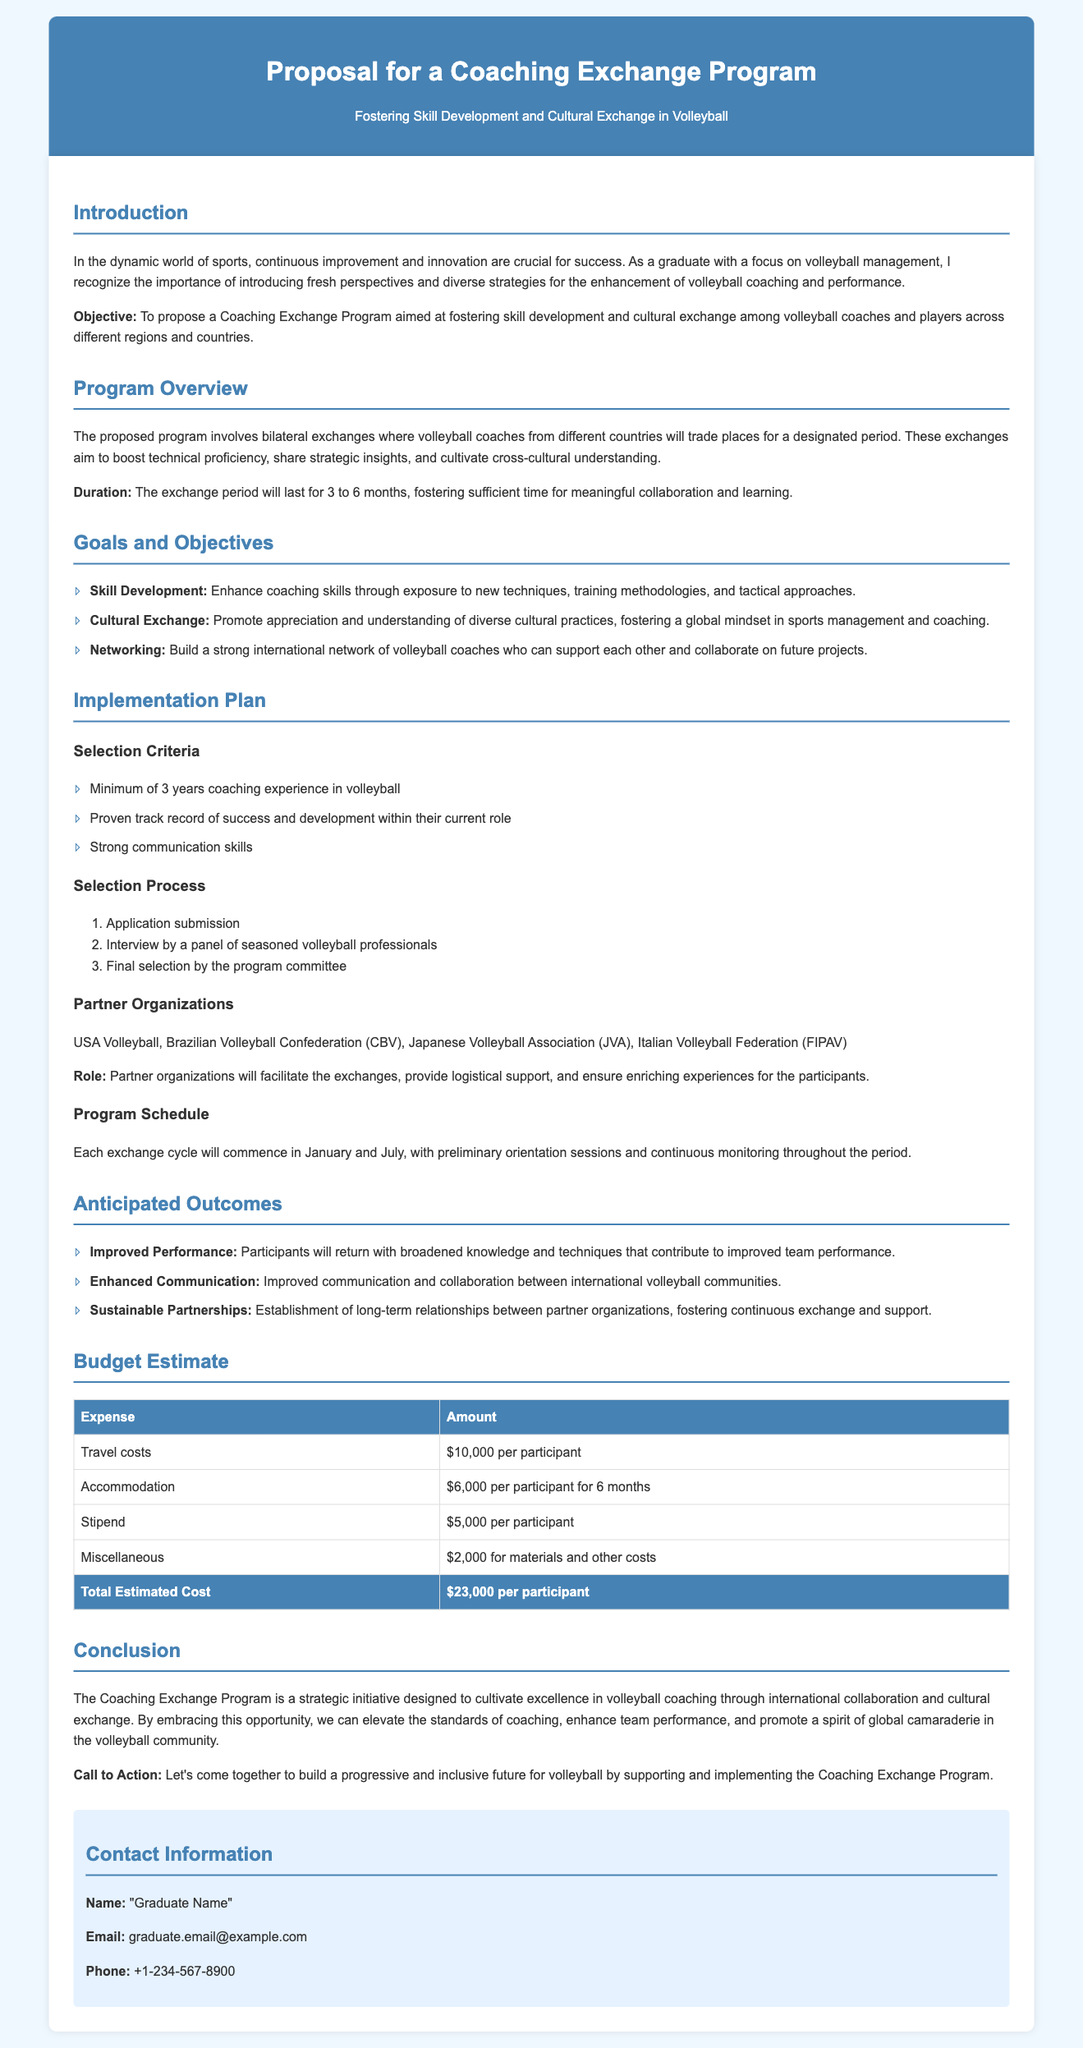what is the duration of the exchange period? The exchange period will last for 3 to 6 months, fostering sufficient time for meaningful collaboration and learning.
Answer: 3 to 6 months who are the partner organizations mentioned? Partner organizations include USA Volleyball, Brazilian Volleyball Confederation (CBV), Japanese Volleyball Association (JVA), and Italian Volleyball Federation (FIPAV).
Answer: USA Volleyball, Brazilian Volleyball Confederation (CBV), Japanese Volleyball Association (JVA), Italian Volleyball Federation (FIPAV) how much is the total estimated cost per participant? The total estimated cost is calculated from various expense categories listed in the budget, totaling $23,000 per participant.
Answer: $23,000 what is a goal of the Coaching Exchange Program? The goals include enhancing coaching skills, promoting cultural exchange, and building a strong international network of volleyball coaches.
Answer: Enhance coaching skills what is the minimum coaching experience required for participants? The selection criteria specify that candidates must have a minimum of 3 years coaching experience in volleyball.
Answer: 3 years what month do the exchange cycles commence? Each exchange cycle is scheduled to commence in January and July, incorporating preliminary orientation sessions.
Answer: January and July what is the budget allocation for travel costs per participant? The document specifies that travel costs amount to $10,000 per participant.
Answer: $10,000 what is the main objective of the proposed program? The objective of the program is to foster skill development and cultural exchange among volleyball coaches and players.
Answer: Foster skill development and cultural exchange 